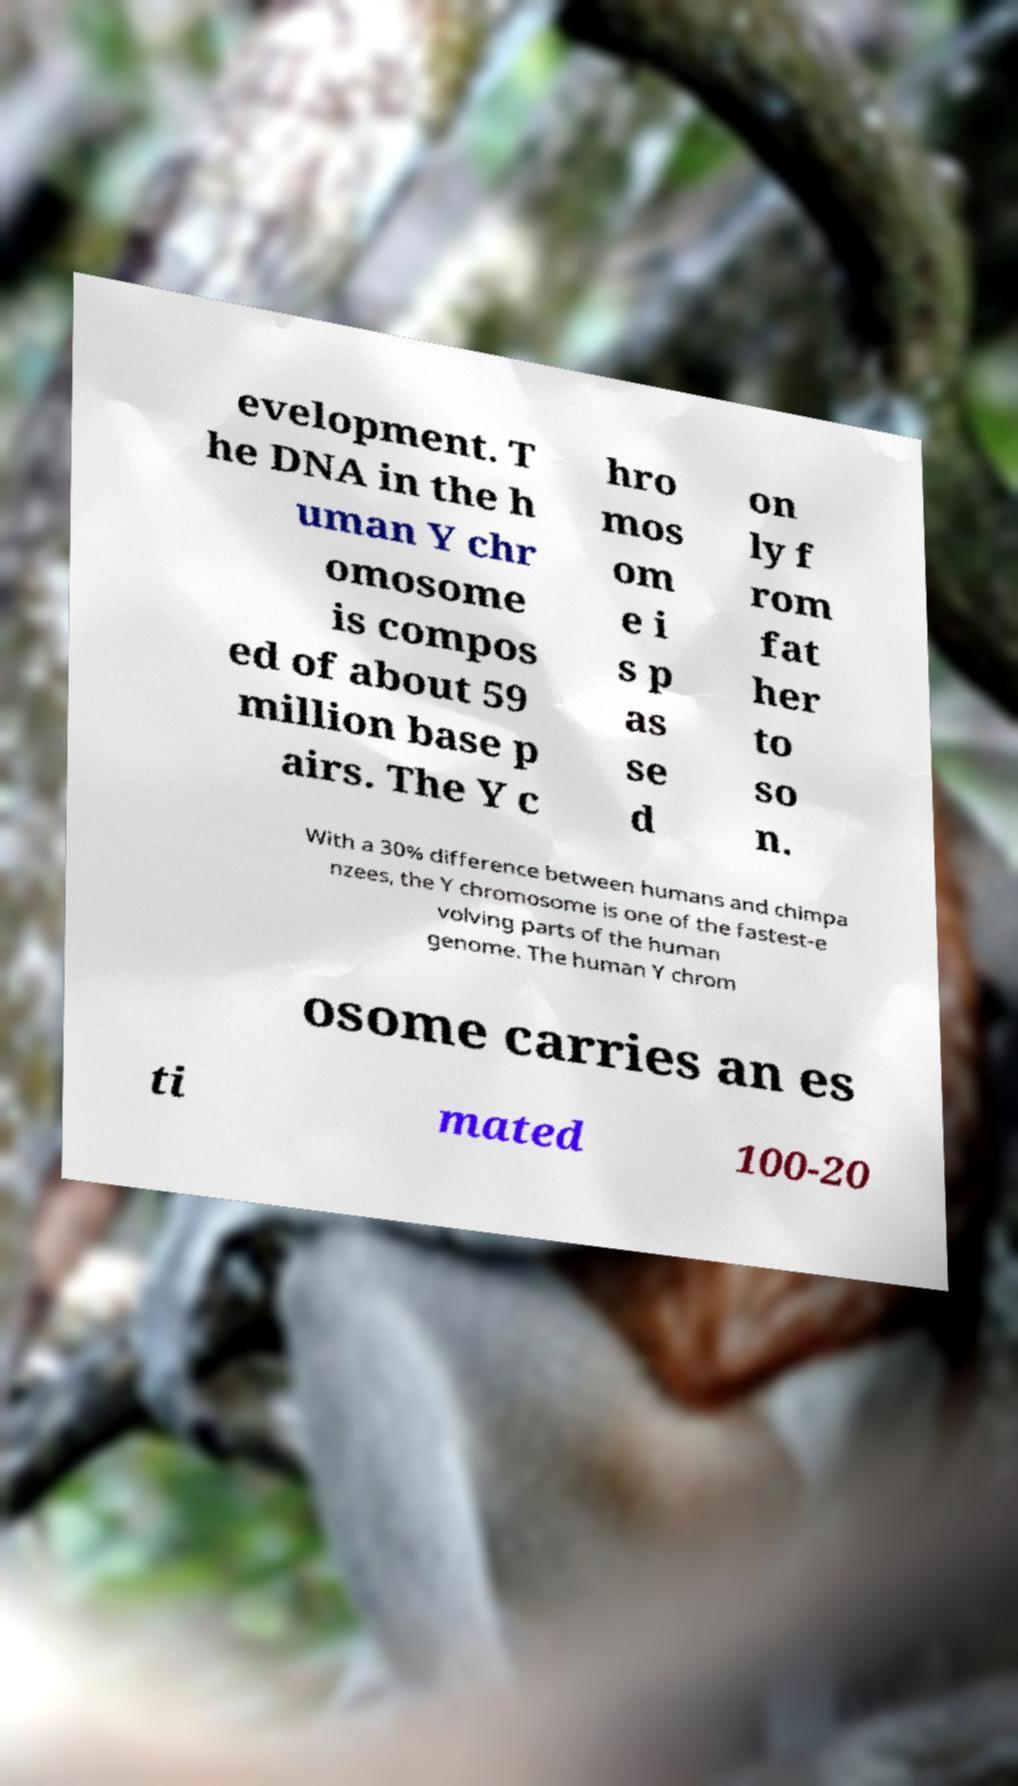Can you accurately transcribe the text from the provided image for me? evelopment. T he DNA in the h uman Y chr omosome is compos ed of about 59 million base p airs. The Y c hro mos om e i s p as se d on ly f rom fat her to so n. With a 30% difference between humans and chimpa nzees, the Y chromosome is one of the fastest-e volving parts of the human genome. The human Y chrom osome carries an es ti mated 100-20 